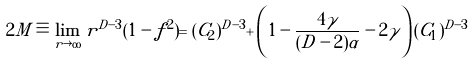Convert formula to latex. <formula><loc_0><loc_0><loc_500><loc_500>2 M \equiv \lim _ { r \rightarrow \infty } r ^ { D - 3 } ( 1 - f ^ { 2 } ) = ( C _ { 2 } ) ^ { D - 3 } + \left ( 1 - \frac { 4 \gamma } { ( D - 2 ) \alpha } - 2 \gamma \right ) ( C _ { 1 } ) ^ { D - 3 }</formula> 